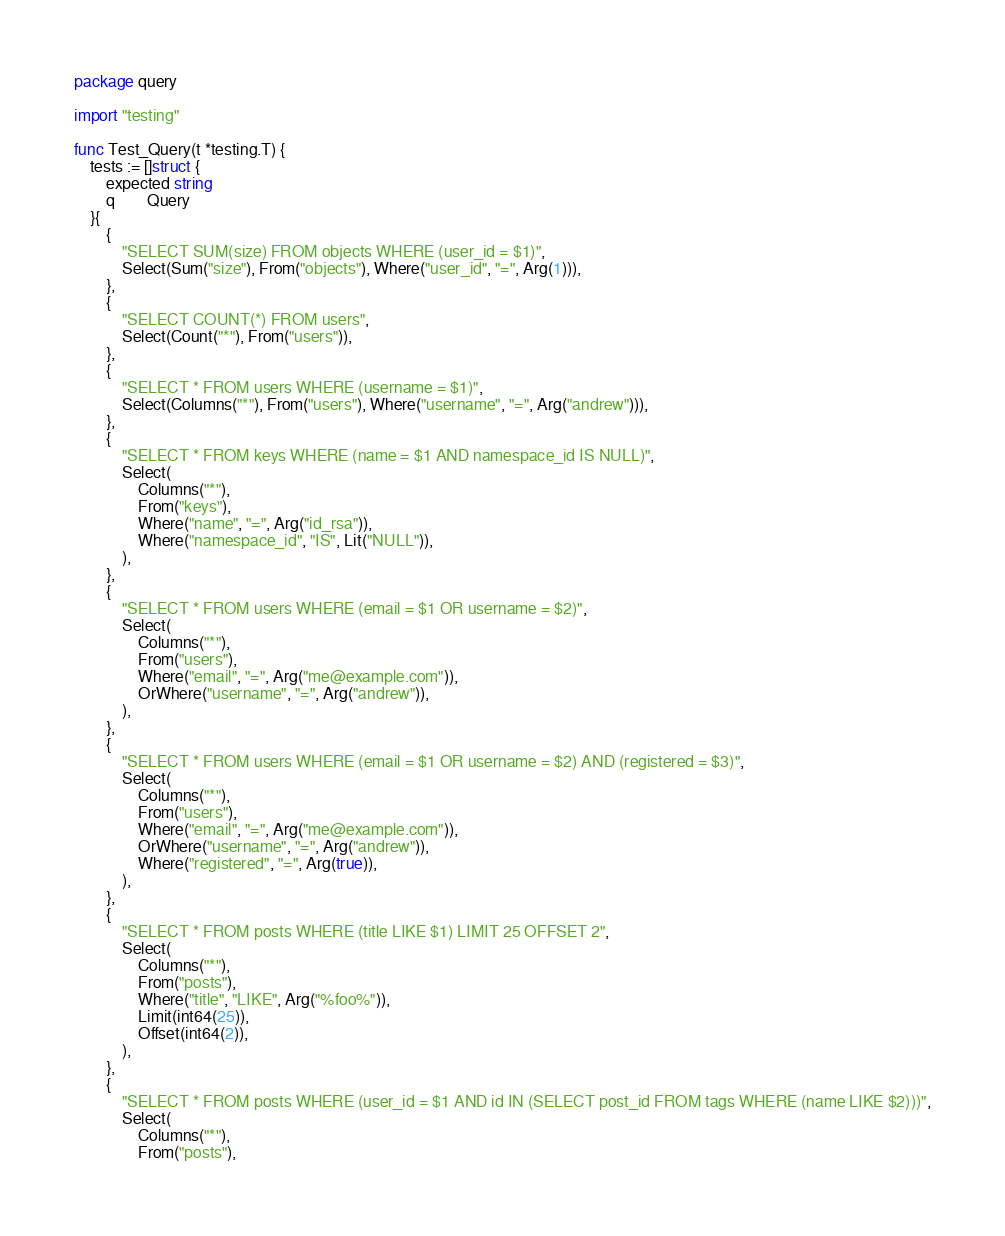<code> <loc_0><loc_0><loc_500><loc_500><_Go_>package query

import "testing"

func Test_Query(t *testing.T) {
	tests := []struct {
		expected string
		q        Query
	}{
		{
			"SELECT SUM(size) FROM objects WHERE (user_id = $1)",
			Select(Sum("size"), From("objects"), Where("user_id", "=", Arg(1))),
		},
		{
			"SELECT COUNT(*) FROM users",
			Select(Count("*"), From("users")),
		},
		{
			"SELECT * FROM users WHERE (username = $1)",
			Select(Columns("*"), From("users"), Where("username", "=", Arg("andrew"))),
		},
		{
			"SELECT * FROM keys WHERE (name = $1 AND namespace_id IS NULL)",
			Select(
				Columns("*"),
				From("keys"),
				Where("name", "=", Arg("id_rsa")),
				Where("namespace_id", "IS", Lit("NULL")),
			),
		},
		{
			"SELECT * FROM users WHERE (email = $1 OR username = $2)",
			Select(
				Columns("*"),
				From("users"),
				Where("email", "=", Arg("me@example.com")),
				OrWhere("username", "=", Arg("andrew")),
			),
		},
		{
			"SELECT * FROM users WHERE (email = $1 OR username = $2) AND (registered = $3)",
			Select(
				Columns("*"),
				From("users"),
				Where("email", "=", Arg("me@example.com")),
				OrWhere("username", "=", Arg("andrew")),
				Where("registered", "=", Arg(true)),
			),
		},
		{
			"SELECT * FROM posts WHERE (title LIKE $1) LIMIT 25 OFFSET 2",
			Select(
				Columns("*"),
				From("posts"),
				Where("title", "LIKE", Arg("%foo%")),
				Limit(int64(25)),
				Offset(int64(2)),
			),
		},
		{
			"SELECT * FROM posts WHERE (user_id = $1 AND id IN (SELECT post_id FROM tags WHERE (name LIKE $2)))",
			Select(
				Columns("*"),
				From("posts"),</code> 